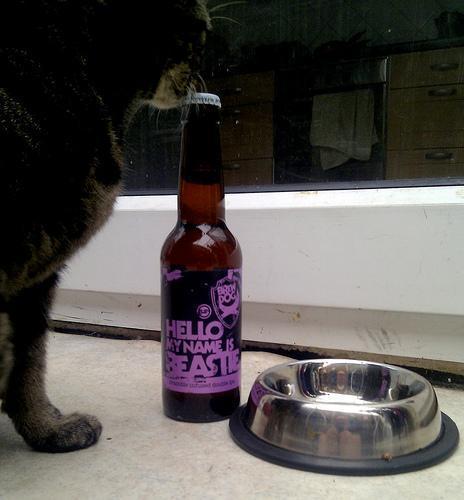How many bottles?
Give a very brief answer. 1. 